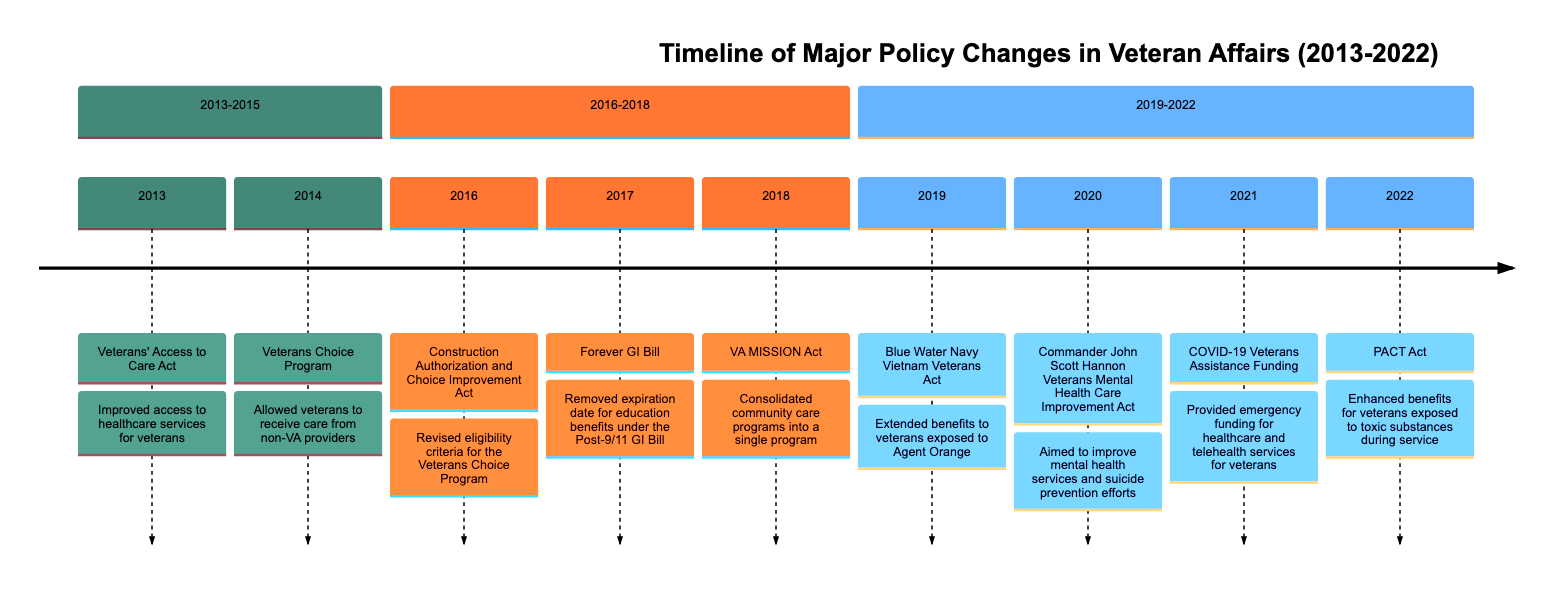What major policy change was enacted in 2013? The diagram specifies that the major policy change in 2013 was the Veterans' Access to Care Act.
Answer: Veterans' Access to Care Act How many major policy changes occurred between 2013 and 2015? In the section between 2013 and 2015, the diagram lists two major policy changes: the Veterans' Access to Care Act and the Veterans Choice Program.
Answer: 2 Which act eliminated the expiration date for education benefits? The diagram clearly shows that the Forever GI Bill, enacted in 2017, removed the expiration date for education benefits.
Answer: Forever GI Bill What year did the PACT Act get established? The diagram indicates that the PACT Act was established in 2022, as it is the last policy change listed in the timeline.
Answer: 2022 What was the focus of the Commander John Scott Hannon Veterans Mental Health Care Improvement Act? According to the diagram, this act aimed to improve mental health services and enhance efforts for suicide prevention, as specified in the description.
Answer: Mental health services and suicide prevention Which policy act revised eligibility for the Veterans Choice Program? The timeline shows that the Construction Authorization and Choice Improvement Act, implemented in 2016, revised the eligibility criteria for the Veterans Choice Program.
Answer: Construction Authorization and Choice Improvement Act What significant change occurred in 2019 regarding Agent Orange exposure? The Blue Water Navy Vietnam Veterans Act, enacted in 2019, is noted on the diagram for extending benefits to veterans who were exposed to Agent Orange.
Answer: Extended benefits for veterans exposed to Agent Orange How many major policy changes were listed in the 2019-2022 section? The diagram outlines four major policy changes in the period from 2019 to 2022, which include acts from 2019, 2020, 2021, and 2022.
Answer: 4 What did the VA MISSION Act consolidate? The diagram specifies that the VA MISSION Act, established in 2018, consolidated community care programs into a single program.
Answer: Community care programs 